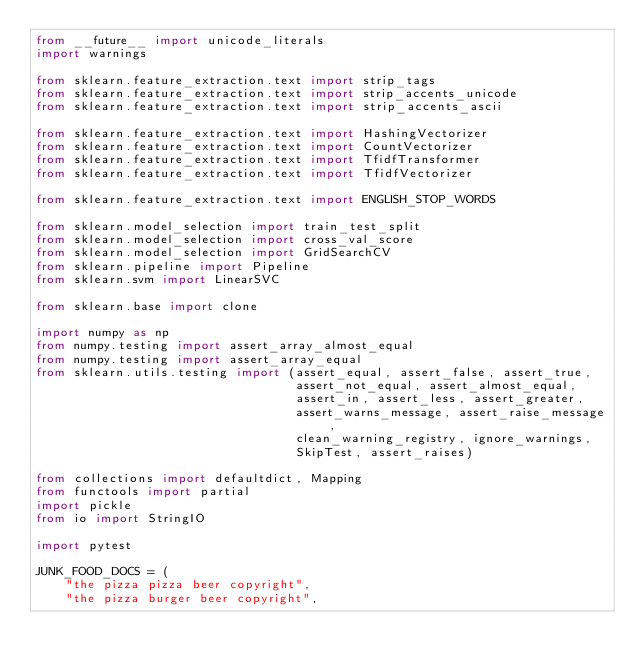Convert code to text. <code><loc_0><loc_0><loc_500><loc_500><_Python_>from __future__ import unicode_literals
import warnings

from sklearn.feature_extraction.text import strip_tags
from sklearn.feature_extraction.text import strip_accents_unicode
from sklearn.feature_extraction.text import strip_accents_ascii

from sklearn.feature_extraction.text import HashingVectorizer
from sklearn.feature_extraction.text import CountVectorizer
from sklearn.feature_extraction.text import TfidfTransformer
from sklearn.feature_extraction.text import TfidfVectorizer

from sklearn.feature_extraction.text import ENGLISH_STOP_WORDS

from sklearn.model_selection import train_test_split
from sklearn.model_selection import cross_val_score
from sklearn.model_selection import GridSearchCV
from sklearn.pipeline import Pipeline
from sklearn.svm import LinearSVC

from sklearn.base import clone

import numpy as np
from numpy.testing import assert_array_almost_equal
from numpy.testing import assert_array_equal
from sklearn.utils.testing import (assert_equal, assert_false, assert_true,
                                   assert_not_equal, assert_almost_equal,
                                   assert_in, assert_less, assert_greater,
                                   assert_warns_message, assert_raise_message,
                                   clean_warning_registry, ignore_warnings,
                                   SkipTest, assert_raises)

from collections import defaultdict, Mapping
from functools import partial
import pickle
from io import StringIO

import pytest

JUNK_FOOD_DOCS = (
    "the pizza pizza beer copyright",
    "the pizza burger beer copyright",</code> 